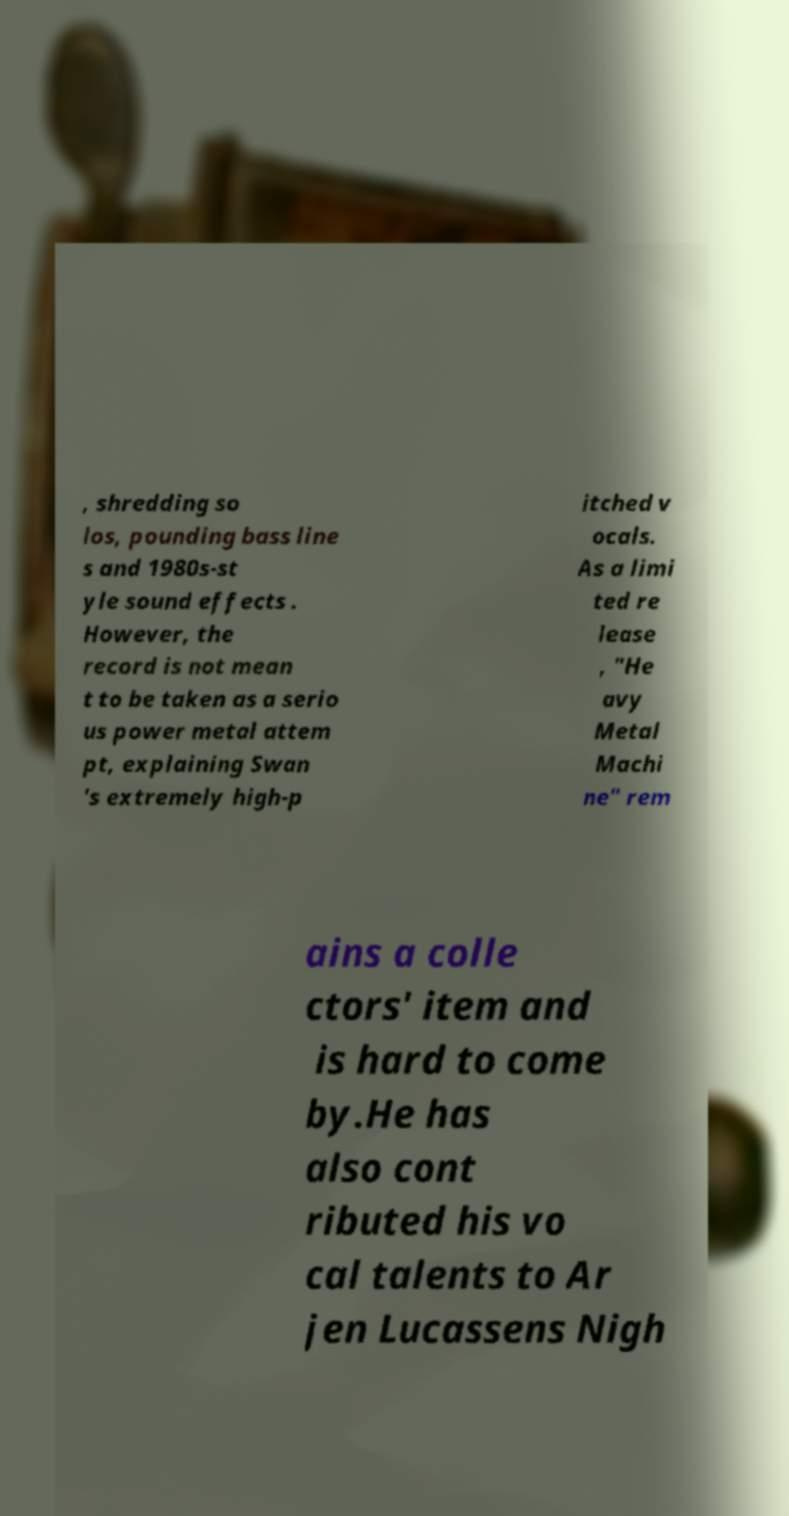I need the written content from this picture converted into text. Can you do that? , shredding so los, pounding bass line s and 1980s-st yle sound effects . However, the record is not mean t to be taken as a serio us power metal attem pt, explaining Swan 's extremely high-p itched v ocals. As a limi ted re lease , "He avy Metal Machi ne" rem ains a colle ctors' item and is hard to come by.He has also cont ributed his vo cal talents to Ar jen Lucassens Nigh 